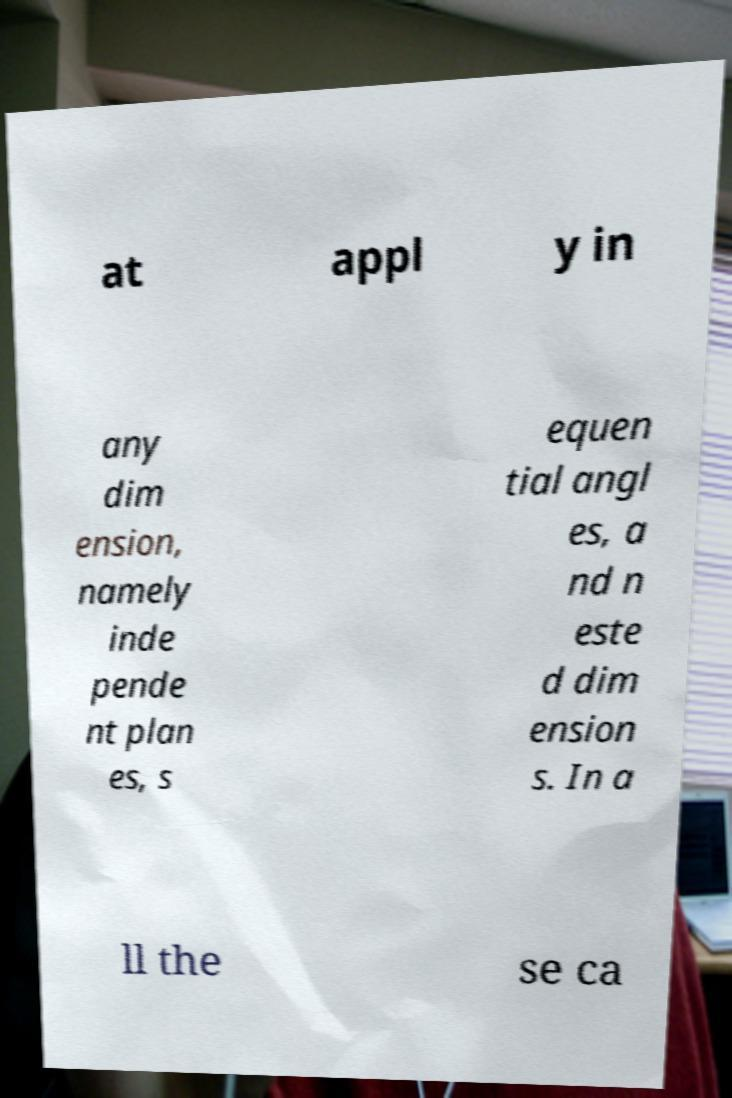Please read and relay the text visible in this image. What does it say? at appl y in any dim ension, namely inde pende nt plan es, s equen tial angl es, a nd n este d dim ension s. In a ll the se ca 